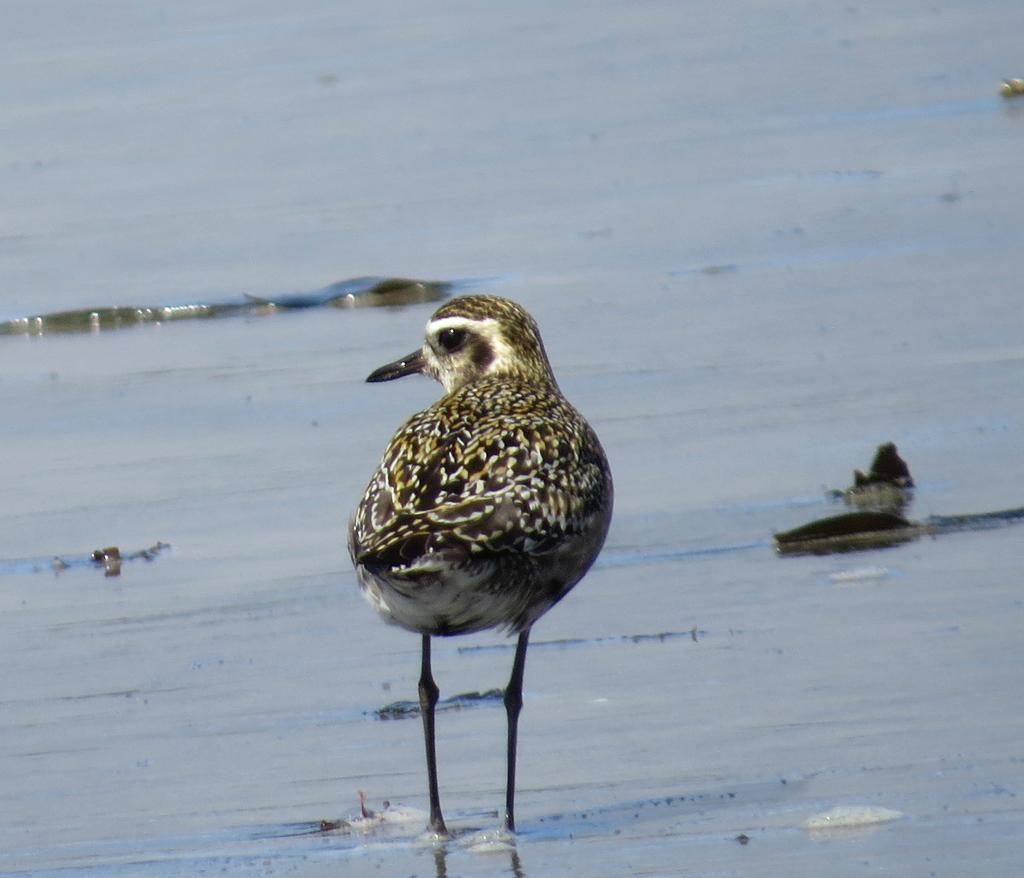What type of animal is in the image? There is a bird in the image. Where is the bird located in the image? The bird is in water. What type of shade does the bird provide in the image? The image does not show the bird providing any shade, as it is in the water. Is there a bike visible in the image? No, there is no bike present in the image. 